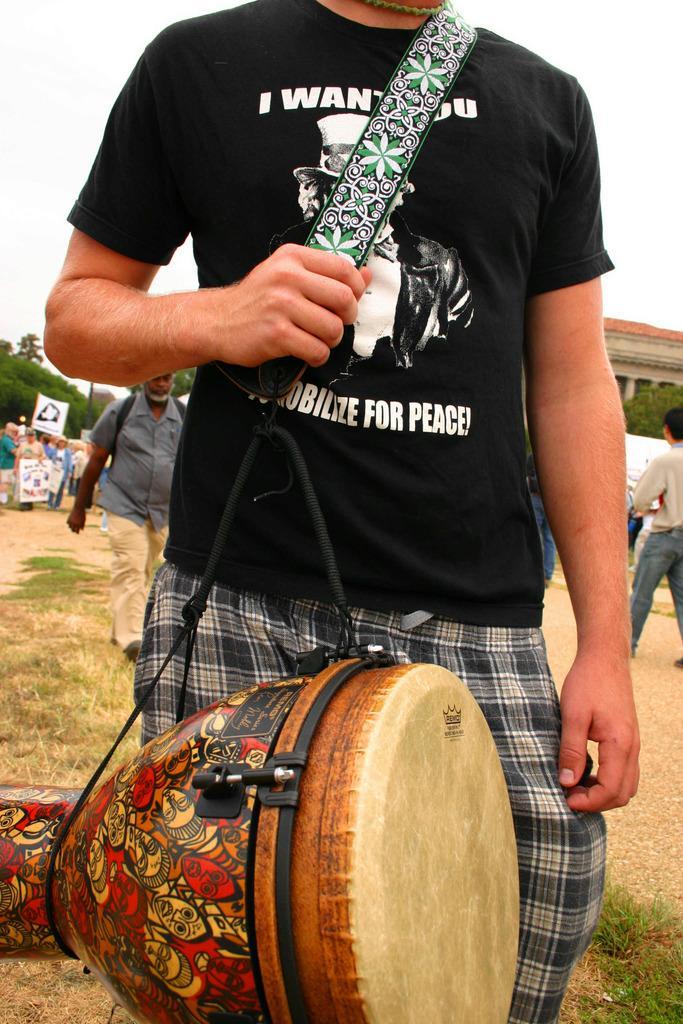Can you describe this image briefly? In the given image we can see there are many people. This is a musical band, tree, grass and white sky. 